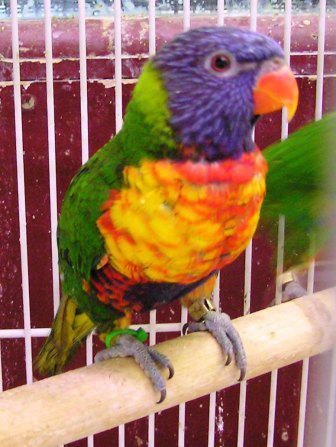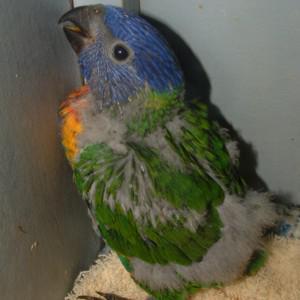The first image is the image on the left, the second image is the image on the right. Assess this claim about the two images: "There are three birds with blue head.". Correct or not? Answer yes or no. No. The first image is the image on the left, the second image is the image on the right. Evaluate the accuracy of this statement regarding the images: "An image shows a parrot with spread wings on top of a parrot that is on the ground.". Is it true? Answer yes or no. No. 